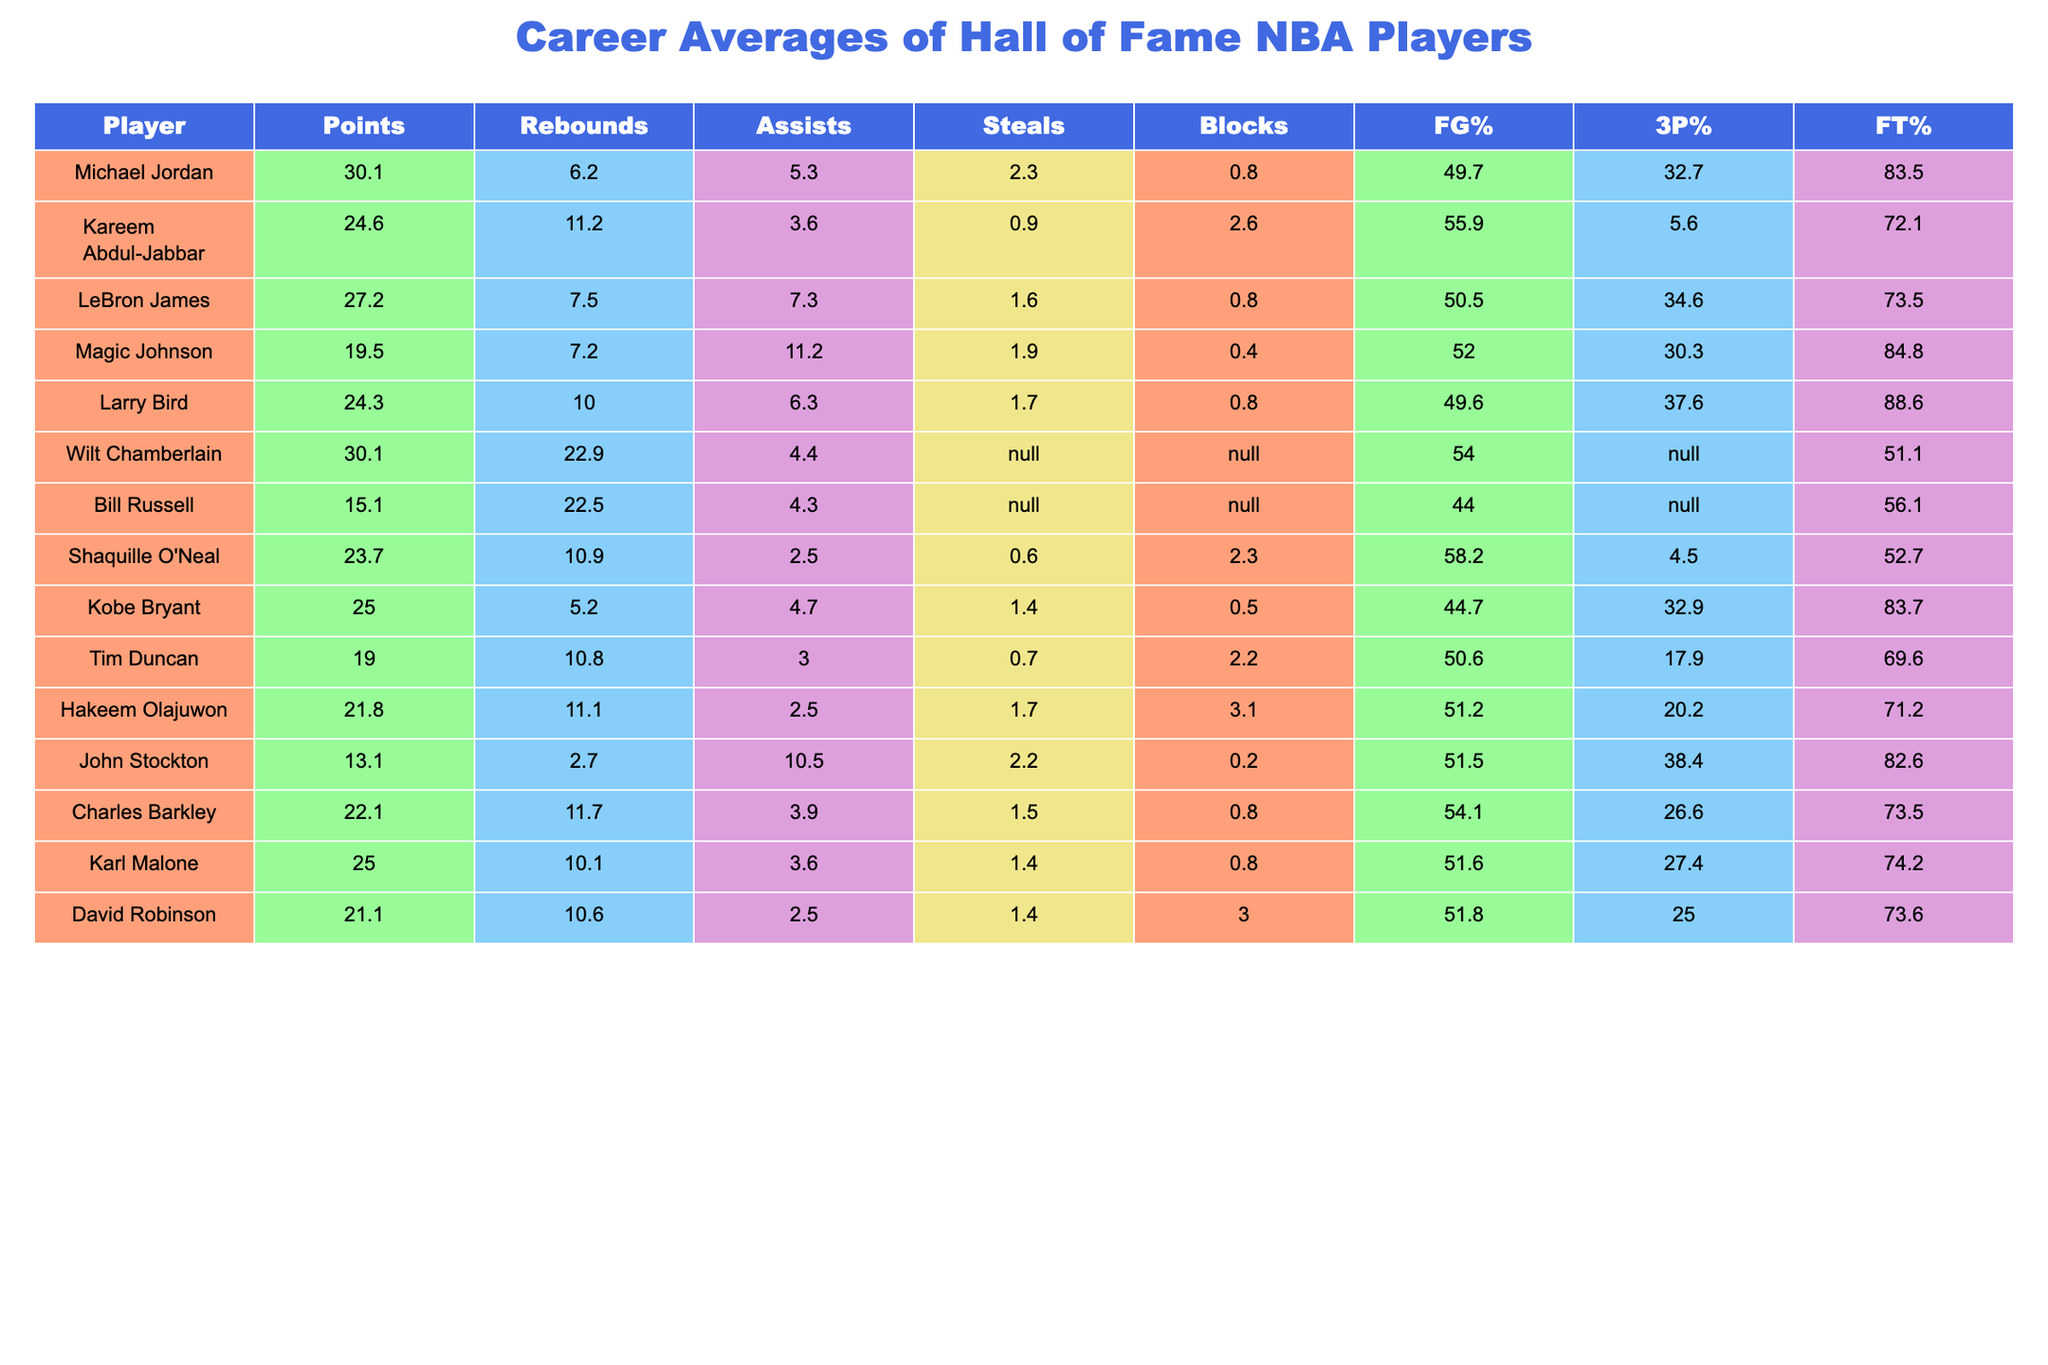Which player has the highest career points average? The table indicates that both Michael Jordan and Wilt Chamberlain have a career points average of 30.1, which is the highest among all players.
Answer: Michael Jordan and Wilt Chamberlain What is LeBron James' average in assists? Referring to the table, LeBron James has an average of 7.3 assists per game.
Answer: 7.3 Which player has the highest rebounds average and what is it? The table shows that Wilt Chamberlain has the highest rebounds average with 22.9 per game.
Answer: 22.9 Is Shaquille O'Neal's field goal percentage higher than Charles Barkley's? By checking the table, Shaquille O'Neal has a field goal percentage of 58.2, while Charles Barkley has 54.1, thus O'Neal's percentage is higher.
Answer: Yes What is the average free throw percentage of Magic Johnson and John Stockton combined? Magic Johnson's free throw percentage is 84.8 and John Stockton's is 82.6. Adding both gives 84.8 + 82.6 = 167.4, and dividing by 2 (since there are 2 players) yields an average of 83.7.
Answer: 83.7 How many players have a steals average above 2.0? The table shows that Michael Jordan (2.3), LeBron James (1.6), John Stockton (2.2), and Hakeem Olajuwon (1.7) are considered. Thus only Michael Jordan and John Stockton exceed 2.0.
Answer: 2 players Which player has the lowest average in points and assists combined? Analyzing the table, Bill Russell has the lowest average of points (15.1) and assists (4.3) combined, totaling 19.4.
Answer: Bill Russell Determine the difference in average blocks per game between Hakeem Olajuwon and Tim Duncan. Hakeem Olajuwon averages 3.1 blocks per game while Tim Duncan averages 2.2 blocks. The difference is 3.1 - 2.2 = 0.9.
Answer: 0.9 Who has a higher three-point shooting percentage: Larry Bird or Kareem Abdul-Jabbar? The table indicates that Larry Bird has a three-point shooting percentage of 37.6, while Kareem Abdul-Jabbar has 5.6. Therefore, Bird has a higher percentage.
Answer: Yes What is the total career averages in rebounds for the top three players based on their averages? The top three players in rebounds are Wilt Chamberlain (22.9), Bill Russell (22.5), and Hakeem Olajuwon (11.1). Adding them gives 22.9 + 22.5 + 11.1 = 56.5.
Answer: 56.5 